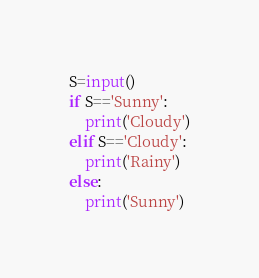Convert code to text. <code><loc_0><loc_0><loc_500><loc_500><_Python_>S=input()
if S=='Sunny':
    print('Cloudy')
elif S=='Cloudy':
    print('Rainy')
else:
    print('Sunny')</code> 